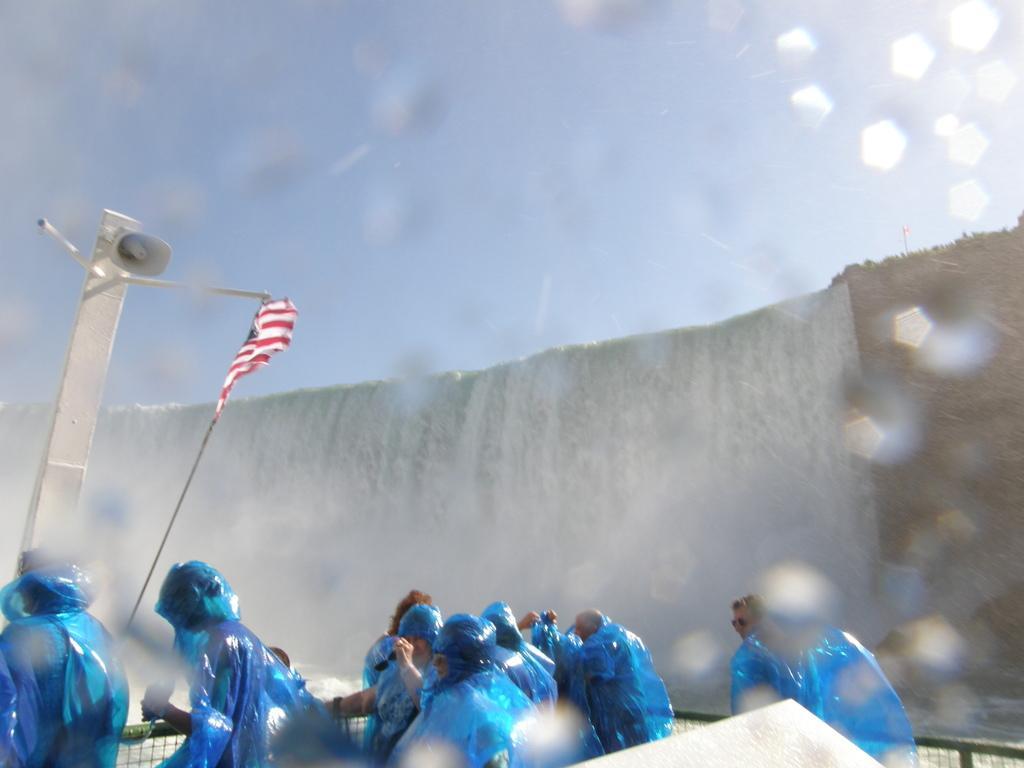Please provide a concise description of this image. In this image we can see few people wearing raincoat. Image also consists of speaker to the pole and also fence and a flag. Sky is also visible at the top and this image is taken near the waterfalls. 